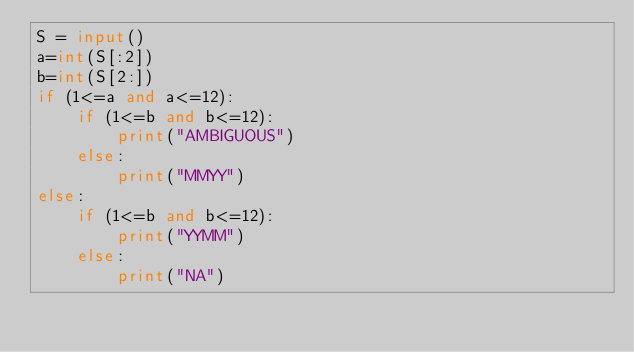<code> <loc_0><loc_0><loc_500><loc_500><_Python_>S = input()
a=int(S[:2])
b=int(S[2:])
if (1<=a and a<=12):   
    if (1<=b and b<=12):
        print("AMBIGUOUS")
    else:
        print("MMYY")
else:
    if (1<=b and b<=12):
        print("YYMM")
    else:
        print("NA")</code> 